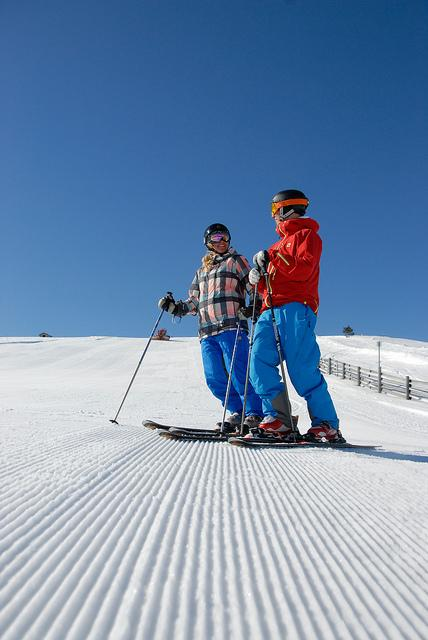Why are they so close together?

Choices:
A) curious
B) friendly
C) accidental
D) angry friendly 